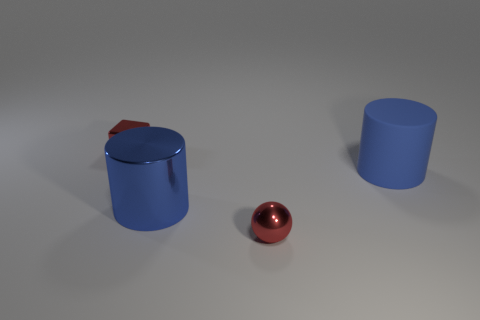Add 1 tiny balls. How many objects exist? 5 Subtract all cubes. How many objects are left? 3 Add 2 large matte things. How many large matte things are left? 3 Add 3 large blue things. How many large blue things exist? 5 Subtract 0 green spheres. How many objects are left? 4 Subtract all matte cylinders. Subtract all big blue cylinders. How many objects are left? 1 